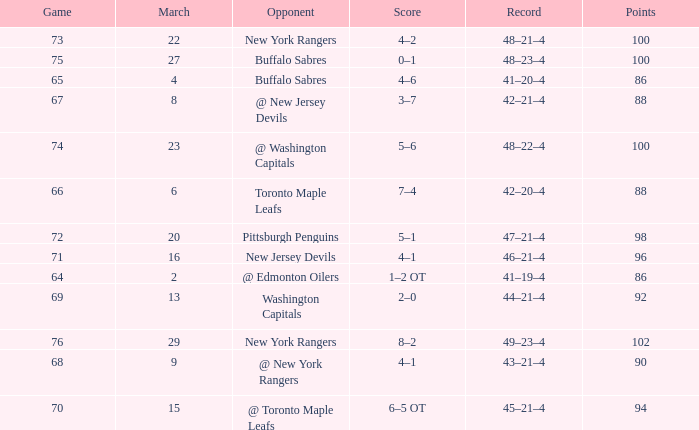Which Score has a March larger than 15, and Points larger than 96, and a Game smaller than 76, and an Opponent of @ washington capitals? 5–6. 